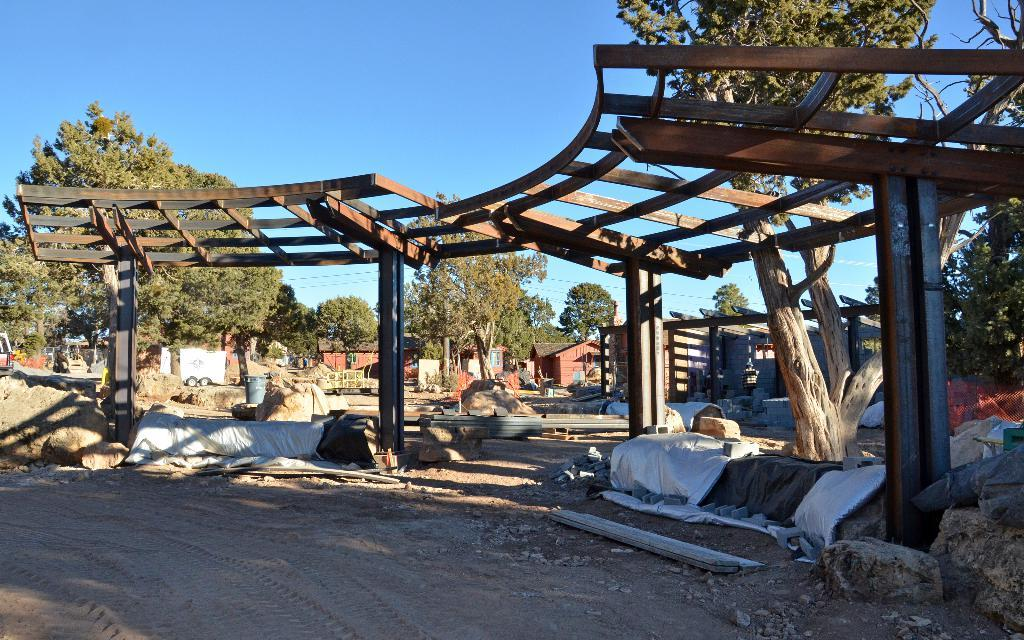What type of structures can be seen in the image? There are sheds in the image. What other objects can be found in the image? There are stones in the image. What can be seen in the background of the image? There are trees and houses in the background of the image. What is the color of the sky in the image? The sky is blue in the image. How much debt does the monkey in the image have? There is no monkey present in the image, so it is not possible to determine any debt. 